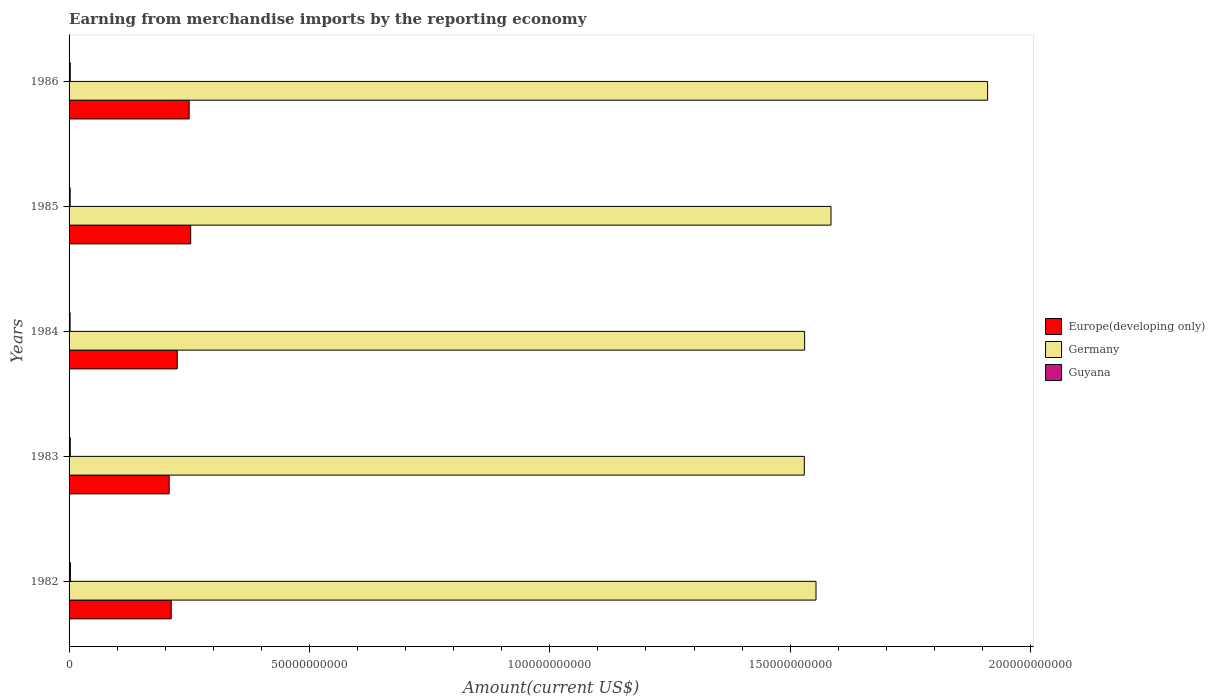How many groups of bars are there?
Give a very brief answer. 5. Are the number of bars per tick equal to the number of legend labels?
Ensure brevity in your answer.  Yes. Are the number of bars on each tick of the Y-axis equal?
Provide a succinct answer. Yes. What is the label of the 4th group of bars from the top?
Give a very brief answer. 1983. In how many cases, is the number of bars for a given year not equal to the number of legend labels?
Your answer should be very brief. 0. What is the amount earned from merchandise imports in Germany in 1986?
Provide a succinct answer. 1.91e+11. Across all years, what is the maximum amount earned from merchandise imports in Guyana?
Your answer should be very brief. 2.80e+08. Across all years, what is the minimum amount earned from merchandise imports in Guyana?
Provide a short and direct response. 2.12e+08. In which year was the amount earned from merchandise imports in Germany maximum?
Provide a succinct answer. 1986. What is the total amount earned from merchandise imports in Germany in the graph?
Ensure brevity in your answer.  8.11e+11. What is the difference between the amount earned from merchandise imports in Guyana in 1985 and that in 1986?
Your response must be concise. -1.70e+07. What is the difference between the amount earned from merchandise imports in Guyana in 1983 and the amount earned from merchandise imports in Europe(developing only) in 1984?
Offer a terse response. -2.22e+1. What is the average amount earned from merchandise imports in Europe(developing only) per year?
Provide a short and direct response. 2.30e+1. In the year 1985, what is the difference between the amount earned from merchandise imports in Guyana and amount earned from merchandise imports in Europe(developing only)?
Give a very brief answer. -2.51e+1. What is the ratio of the amount earned from merchandise imports in Germany in 1982 to that in 1984?
Keep it short and to the point. 1.02. Is the amount earned from merchandise imports in Europe(developing only) in 1984 less than that in 1985?
Offer a very short reply. Yes. Is the difference between the amount earned from merchandise imports in Guyana in 1985 and 1986 greater than the difference between the amount earned from merchandise imports in Europe(developing only) in 1985 and 1986?
Your answer should be very brief. No. What is the difference between the highest and the second highest amount earned from merchandise imports in Germany?
Your answer should be very brief. 3.26e+1. What is the difference between the highest and the lowest amount earned from merchandise imports in Germany?
Provide a short and direct response. 3.81e+1. Is the sum of the amount earned from merchandise imports in Germany in 1984 and 1986 greater than the maximum amount earned from merchandise imports in Guyana across all years?
Keep it short and to the point. Yes. What does the 2nd bar from the top in 1985 represents?
Offer a terse response. Germany. What does the 3rd bar from the bottom in 1983 represents?
Offer a very short reply. Guyana. How many bars are there?
Make the answer very short. 15. Are all the bars in the graph horizontal?
Your response must be concise. Yes. Are the values on the major ticks of X-axis written in scientific E-notation?
Give a very brief answer. No. Does the graph contain any zero values?
Ensure brevity in your answer.  No. Does the graph contain grids?
Ensure brevity in your answer.  No. What is the title of the graph?
Your answer should be very brief. Earning from merchandise imports by the reporting economy. What is the label or title of the X-axis?
Offer a terse response. Amount(current US$). What is the Amount(current US$) of Europe(developing only) in 1982?
Provide a short and direct response. 2.12e+1. What is the Amount(current US$) in Germany in 1982?
Provide a short and direct response. 1.55e+11. What is the Amount(current US$) in Guyana in 1982?
Your answer should be compact. 2.80e+08. What is the Amount(current US$) in Europe(developing only) in 1983?
Make the answer very short. 2.08e+1. What is the Amount(current US$) in Germany in 1983?
Your answer should be compact. 1.53e+11. What is the Amount(current US$) in Guyana in 1983?
Keep it short and to the point. 2.52e+08. What is the Amount(current US$) in Europe(developing only) in 1984?
Your answer should be very brief. 2.25e+1. What is the Amount(current US$) in Germany in 1984?
Provide a short and direct response. 1.53e+11. What is the Amount(current US$) of Guyana in 1984?
Give a very brief answer. 2.12e+08. What is the Amount(current US$) of Europe(developing only) in 1985?
Offer a terse response. 2.53e+1. What is the Amount(current US$) of Germany in 1985?
Provide a succinct answer. 1.58e+11. What is the Amount(current US$) of Guyana in 1985?
Your response must be concise. 2.25e+08. What is the Amount(current US$) in Europe(developing only) in 1986?
Make the answer very short. 2.50e+1. What is the Amount(current US$) in Germany in 1986?
Give a very brief answer. 1.91e+11. What is the Amount(current US$) of Guyana in 1986?
Provide a short and direct response. 2.42e+08. Across all years, what is the maximum Amount(current US$) in Europe(developing only)?
Make the answer very short. 2.53e+1. Across all years, what is the maximum Amount(current US$) in Germany?
Provide a succinct answer. 1.91e+11. Across all years, what is the maximum Amount(current US$) of Guyana?
Ensure brevity in your answer.  2.80e+08. Across all years, what is the minimum Amount(current US$) in Europe(developing only)?
Your answer should be compact. 2.08e+1. Across all years, what is the minimum Amount(current US$) in Germany?
Keep it short and to the point. 1.53e+11. Across all years, what is the minimum Amount(current US$) of Guyana?
Your answer should be very brief. 2.12e+08. What is the total Amount(current US$) in Europe(developing only) in the graph?
Offer a very short reply. 1.15e+11. What is the total Amount(current US$) in Germany in the graph?
Offer a terse response. 8.11e+11. What is the total Amount(current US$) in Guyana in the graph?
Keep it short and to the point. 1.21e+09. What is the difference between the Amount(current US$) in Europe(developing only) in 1982 and that in 1983?
Provide a succinct answer. 4.28e+08. What is the difference between the Amount(current US$) in Germany in 1982 and that in 1983?
Offer a very short reply. 2.44e+09. What is the difference between the Amount(current US$) in Guyana in 1982 and that in 1983?
Offer a very short reply. 2.84e+07. What is the difference between the Amount(current US$) in Europe(developing only) in 1982 and that in 1984?
Offer a very short reply. -1.25e+09. What is the difference between the Amount(current US$) in Germany in 1982 and that in 1984?
Offer a terse response. 2.37e+09. What is the difference between the Amount(current US$) in Guyana in 1982 and that in 1984?
Make the answer very short. 6.82e+07. What is the difference between the Amount(current US$) in Europe(developing only) in 1982 and that in 1985?
Provide a short and direct response. -4.05e+09. What is the difference between the Amount(current US$) in Germany in 1982 and that in 1985?
Keep it short and to the point. -3.11e+09. What is the difference between the Amount(current US$) in Guyana in 1982 and that in 1985?
Give a very brief answer. 5.47e+07. What is the difference between the Amount(current US$) in Europe(developing only) in 1982 and that in 1986?
Keep it short and to the point. -3.73e+09. What is the difference between the Amount(current US$) in Germany in 1982 and that in 1986?
Your answer should be very brief. -3.57e+1. What is the difference between the Amount(current US$) of Guyana in 1982 and that in 1986?
Give a very brief answer. 3.77e+07. What is the difference between the Amount(current US$) of Europe(developing only) in 1983 and that in 1984?
Offer a very short reply. -1.68e+09. What is the difference between the Amount(current US$) of Germany in 1983 and that in 1984?
Ensure brevity in your answer.  -6.60e+07. What is the difference between the Amount(current US$) in Guyana in 1983 and that in 1984?
Give a very brief answer. 3.97e+07. What is the difference between the Amount(current US$) of Europe(developing only) in 1983 and that in 1985?
Give a very brief answer. -4.48e+09. What is the difference between the Amount(current US$) of Germany in 1983 and that in 1985?
Provide a short and direct response. -5.55e+09. What is the difference between the Amount(current US$) of Guyana in 1983 and that in 1985?
Offer a very short reply. 2.63e+07. What is the difference between the Amount(current US$) of Europe(developing only) in 1983 and that in 1986?
Your response must be concise. -4.16e+09. What is the difference between the Amount(current US$) in Germany in 1983 and that in 1986?
Ensure brevity in your answer.  -3.81e+1. What is the difference between the Amount(current US$) in Guyana in 1983 and that in 1986?
Provide a succinct answer. 9.24e+06. What is the difference between the Amount(current US$) of Europe(developing only) in 1984 and that in 1985?
Give a very brief answer. -2.80e+09. What is the difference between the Amount(current US$) in Germany in 1984 and that in 1985?
Offer a terse response. -5.48e+09. What is the difference between the Amount(current US$) of Guyana in 1984 and that in 1985?
Provide a short and direct response. -1.35e+07. What is the difference between the Amount(current US$) of Europe(developing only) in 1984 and that in 1986?
Provide a short and direct response. -2.48e+09. What is the difference between the Amount(current US$) in Germany in 1984 and that in 1986?
Provide a short and direct response. -3.81e+1. What is the difference between the Amount(current US$) in Guyana in 1984 and that in 1986?
Give a very brief answer. -3.05e+07. What is the difference between the Amount(current US$) in Europe(developing only) in 1985 and that in 1986?
Keep it short and to the point. 3.18e+08. What is the difference between the Amount(current US$) of Germany in 1985 and that in 1986?
Your response must be concise. -3.26e+1. What is the difference between the Amount(current US$) in Guyana in 1985 and that in 1986?
Your response must be concise. -1.70e+07. What is the difference between the Amount(current US$) in Europe(developing only) in 1982 and the Amount(current US$) in Germany in 1983?
Give a very brief answer. -1.32e+11. What is the difference between the Amount(current US$) in Europe(developing only) in 1982 and the Amount(current US$) in Guyana in 1983?
Keep it short and to the point. 2.10e+1. What is the difference between the Amount(current US$) of Germany in 1982 and the Amount(current US$) of Guyana in 1983?
Keep it short and to the point. 1.55e+11. What is the difference between the Amount(current US$) in Europe(developing only) in 1982 and the Amount(current US$) in Germany in 1984?
Your response must be concise. -1.32e+11. What is the difference between the Amount(current US$) in Europe(developing only) in 1982 and the Amount(current US$) in Guyana in 1984?
Ensure brevity in your answer.  2.10e+1. What is the difference between the Amount(current US$) of Germany in 1982 and the Amount(current US$) of Guyana in 1984?
Your response must be concise. 1.55e+11. What is the difference between the Amount(current US$) in Europe(developing only) in 1982 and the Amount(current US$) in Germany in 1985?
Keep it short and to the point. -1.37e+11. What is the difference between the Amount(current US$) in Europe(developing only) in 1982 and the Amount(current US$) in Guyana in 1985?
Provide a succinct answer. 2.10e+1. What is the difference between the Amount(current US$) in Germany in 1982 and the Amount(current US$) in Guyana in 1985?
Offer a terse response. 1.55e+11. What is the difference between the Amount(current US$) of Europe(developing only) in 1982 and the Amount(current US$) of Germany in 1986?
Provide a succinct answer. -1.70e+11. What is the difference between the Amount(current US$) in Europe(developing only) in 1982 and the Amount(current US$) in Guyana in 1986?
Give a very brief answer. 2.10e+1. What is the difference between the Amount(current US$) in Germany in 1982 and the Amount(current US$) in Guyana in 1986?
Keep it short and to the point. 1.55e+11. What is the difference between the Amount(current US$) of Europe(developing only) in 1983 and the Amount(current US$) of Germany in 1984?
Give a very brief answer. -1.32e+11. What is the difference between the Amount(current US$) of Europe(developing only) in 1983 and the Amount(current US$) of Guyana in 1984?
Offer a terse response. 2.06e+1. What is the difference between the Amount(current US$) in Germany in 1983 and the Amount(current US$) in Guyana in 1984?
Keep it short and to the point. 1.53e+11. What is the difference between the Amount(current US$) of Europe(developing only) in 1983 and the Amount(current US$) of Germany in 1985?
Keep it short and to the point. -1.38e+11. What is the difference between the Amount(current US$) of Europe(developing only) in 1983 and the Amount(current US$) of Guyana in 1985?
Your answer should be very brief. 2.06e+1. What is the difference between the Amount(current US$) in Germany in 1983 and the Amount(current US$) in Guyana in 1985?
Your answer should be very brief. 1.53e+11. What is the difference between the Amount(current US$) of Europe(developing only) in 1983 and the Amount(current US$) of Germany in 1986?
Your response must be concise. -1.70e+11. What is the difference between the Amount(current US$) in Europe(developing only) in 1983 and the Amount(current US$) in Guyana in 1986?
Offer a very short reply. 2.06e+1. What is the difference between the Amount(current US$) in Germany in 1983 and the Amount(current US$) in Guyana in 1986?
Give a very brief answer. 1.53e+11. What is the difference between the Amount(current US$) in Europe(developing only) in 1984 and the Amount(current US$) in Germany in 1985?
Your answer should be compact. -1.36e+11. What is the difference between the Amount(current US$) of Europe(developing only) in 1984 and the Amount(current US$) of Guyana in 1985?
Your answer should be compact. 2.23e+1. What is the difference between the Amount(current US$) of Germany in 1984 and the Amount(current US$) of Guyana in 1985?
Make the answer very short. 1.53e+11. What is the difference between the Amount(current US$) of Europe(developing only) in 1984 and the Amount(current US$) of Germany in 1986?
Make the answer very short. -1.69e+11. What is the difference between the Amount(current US$) in Europe(developing only) in 1984 and the Amount(current US$) in Guyana in 1986?
Keep it short and to the point. 2.23e+1. What is the difference between the Amount(current US$) of Germany in 1984 and the Amount(current US$) of Guyana in 1986?
Ensure brevity in your answer.  1.53e+11. What is the difference between the Amount(current US$) in Europe(developing only) in 1985 and the Amount(current US$) in Germany in 1986?
Provide a succinct answer. -1.66e+11. What is the difference between the Amount(current US$) in Europe(developing only) in 1985 and the Amount(current US$) in Guyana in 1986?
Keep it short and to the point. 2.51e+1. What is the difference between the Amount(current US$) of Germany in 1985 and the Amount(current US$) of Guyana in 1986?
Give a very brief answer. 1.58e+11. What is the average Amount(current US$) of Europe(developing only) per year?
Make the answer very short. 2.30e+1. What is the average Amount(current US$) of Germany per year?
Offer a very short reply. 1.62e+11. What is the average Amount(current US$) in Guyana per year?
Offer a very short reply. 2.42e+08. In the year 1982, what is the difference between the Amount(current US$) of Europe(developing only) and Amount(current US$) of Germany?
Your answer should be very brief. -1.34e+11. In the year 1982, what is the difference between the Amount(current US$) of Europe(developing only) and Amount(current US$) of Guyana?
Provide a short and direct response. 2.10e+1. In the year 1982, what is the difference between the Amount(current US$) in Germany and Amount(current US$) in Guyana?
Provide a succinct answer. 1.55e+11. In the year 1983, what is the difference between the Amount(current US$) in Europe(developing only) and Amount(current US$) in Germany?
Your answer should be very brief. -1.32e+11. In the year 1983, what is the difference between the Amount(current US$) of Europe(developing only) and Amount(current US$) of Guyana?
Your answer should be very brief. 2.06e+1. In the year 1983, what is the difference between the Amount(current US$) of Germany and Amount(current US$) of Guyana?
Ensure brevity in your answer.  1.53e+11. In the year 1984, what is the difference between the Amount(current US$) of Europe(developing only) and Amount(current US$) of Germany?
Your answer should be very brief. -1.31e+11. In the year 1984, what is the difference between the Amount(current US$) of Europe(developing only) and Amount(current US$) of Guyana?
Your answer should be very brief. 2.23e+1. In the year 1984, what is the difference between the Amount(current US$) in Germany and Amount(current US$) in Guyana?
Offer a terse response. 1.53e+11. In the year 1985, what is the difference between the Amount(current US$) of Europe(developing only) and Amount(current US$) of Germany?
Give a very brief answer. -1.33e+11. In the year 1985, what is the difference between the Amount(current US$) of Europe(developing only) and Amount(current US$) of Guyana?
Make the answer very short. 2.51e+1. In the year 1985, what is the difference between the Amount(current US$) in Germany and Amount(current US$) in Guyana?
Provide a succinct answer. 1.58e+11. In the year 1986, what is the difference between the Amount(current US$) of Europe(developing only) and Amount(current US$) of Germany?
Provide a succinct answer. -1.66e+11. In the year 1986, what is the difference between the Amount(current US$) of Europe(developing only) and Amount(current US$) of Guyana?
Offer a very short reply. 2.47e+1. In the year 1986, what is the difference between the Amount(current US$) of Germany and Amount(current US$) of Guyana?
Offer a very short reply. 1.91e+11. What is the ratio of the Amount(current US$) of Europe(developing only) in 1982 to that in 1983?
Give a very brief answer. 1.02. What is the ratio of the Amount(current US$) of Germany in 1982 to that in 1983?
Keep it short and to the point. 1.02. What is the ratio of the Amount(current US$) of Guyana in 1982 to that in 1983?
Ensure brevity in your answer.  1.11. What is the ratio of the Amount(current US$) of Europe(developing only) in 1982 to that in 1984?
Make the answer very short. 0.94. What is the ratio of the Amount(current US$) in Germany in 1982 to that in 1984?
Your answer should be compact. 1.02. What is the ratio of the Amount(current US$) in Guyana in 1982 to that in 1984?
Ensure brevity in your answer.  1.32. What is the ratio of the Amount(current US$) of Europe(developing only) in 1982 to that in 1985?
Keep it short and to the point. 0.84. What is the ratio of the Amount(current US$) of Germany in 1982 to that in 1985?
Your answer should be very brief. 0.98. What is the ratio of the Amount(current US$) in Guyana in 1982 to that in 1985?
Provide a short and direct response. 1.24. What is the ratio of the Amount(current US$) of Europe(developing only) in 1982 to that in 1986?
Keep it short and to the point. 0.85. What is the ratio of the Amount(current US$) in Germany in 1982 to that in 1986?
Provide a succinct answer. 0.81. What is the ratio of the Amount(current US$) in Guyana in 1982 to that in 1986?
Offer a very short reply. 1.16. What is the ratio of the Amount(current US$) of Europe(developing only) in 1983 to that in 1984?
Offer a very short reply. 0.93. What is the ratio of the Amount(current US$) of Guyana in 1983 to that in 1984?
Offer a very short reply. 1.19. What is the ratio of the Amount(current US$) in Europe(developing only) in 1983 to that in 1985?
Provide a short and direct response. 0.82. What is the ratio of the Amount(current US$) of Guyana in 1983 to that in 1985?
Offer a very short reply. 1.12. What is the ratio of the Amount(current US$) of Europe(developing only) in 1983 to that in 1986?
Give a very brief answer. 0.83. What is the ratio of the Amount(current US$) in Germany in 1983 to that in 1986?
Give a very brief answer. 0.8. What is the ratio of the Amount(current US$) of Guyana in 1983 to that in 1986?
Your response must be concise. 1.04. What is the ratio of the Amount(current US$) of Europe(developing only) in 1984 to that in 1985?
Give a very brief answer. 0.89. What is the ratio of the Amount(current US$) in Germany in 1984 to that in 1985?
Offer a terse response. 0.97. What is the ratio of the Amount(current US$) of Guyana in 1984 to that in 1985?
Provide a short and direct response. 0.94. What is the ratio of the Amount(current US$) in Europe(developing only) in 1984 to that in 1986?
Ensure brevity in your answer.  0.9. What is the ratio of the Amount(current US$) in Germany in 1984 to that in 1986?
Your response must be concise. 0.8. What is the ratio of the Amount(current US$) of Guyana in 1984 to that in 1986?
Your answer should be compact. 0.87. What is the ratio of the Amount(current US$) of Europe(developing only) in 1985 to that in 1986?
Your answer should be very brief. 1.01. What is the ratio of the Amount(current US$) in Germany in 1985 to that in 1986?
Your response must be concise. 0.83. What is the ratio of the Amount(current US$) of Guyana in 1985 to that in 1986?
Make the answer very short. 0.93. What is the difference between the highest and the second highest Amount(current US$) in Europe(developing only)?
Provide a short and direct response. 3.18e+08. What is the difference between the highest and the second highest Amount(current US$) of Germany?
Your answer should be compact. 3.26e+1. What is the difference between the highest and the second highest Amount(current US$) of Guyana?
Your answer should be very brief. 2.84e+07. What is the difference between the highest and the lowest Amount(current US$) in Europe(developing only)?
Make the answer very short. 4.48e+09. What is the difference between the highest and the lowest Amount(current US$) in Germany?
Your answer should be very brief. 3.81e+1. What is the difference between the highest and the lowest Amount(current US$) in Guyana?
Ensure brevity in your answer.  6.82e+07. 